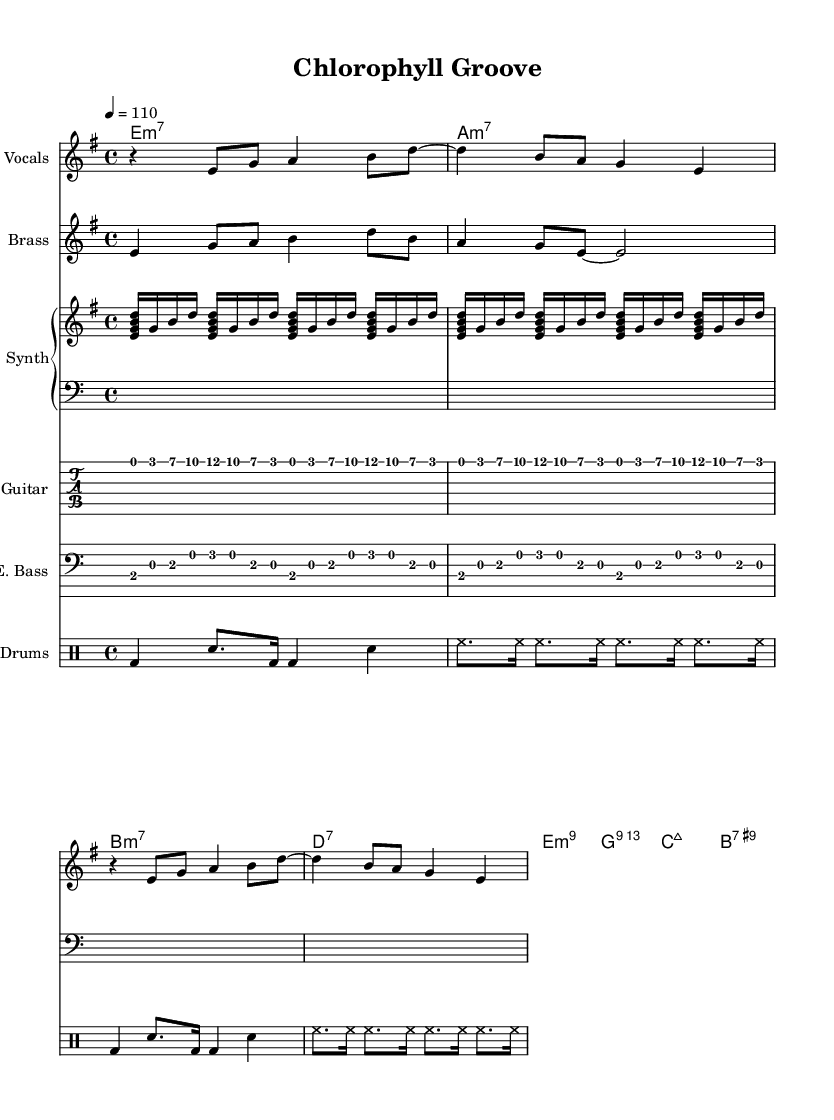What is the key signature of this music? The key signature is E minor, which has one sharp (F#) and follows the standard notation in the beginning of the staff.
Answer: E minor What is the time signature of this music? The time signature is found at the beginning of the sheet music; it shows 4 over 4, indicating four beats per measure, which is common in funk music.
Answer: 4/4 What is the tempo marking for this piece? The tempo marking, typically found above the staff, indicates "4 = 110", meaning one quarter note is equal to 110 beats per minute.
Answer: 110 Which instruments are featured in the score? The score clearly lists several instruments: Vocals, Brass, Synth, Electric Guitar, Electric Bass, and Drums, which are all specified in their respective staves.
Answer: Vocals, Brass, Synth, Electric Guitar, Electric Bass, Drums What chord is played first in the progression? The first chord in the chord names section is E minor 7, indicated at the beginning of the chord progression, which sets the tonal foundation for the piece.
Answer: E minor 7 How many times is the main electric guitar riff repeated? By looking at the electric guitar part, it is noted that the riff is explicitly noted to repeat twice in the score, as indicated by the repeat markings.
Answer: 2 What rhythmic division is used in the drum patterns? The drum section indicates a mix of quarter, eighth, and sixteenth notes, showcasing the syncopated groove typical of funk music, particularly in the alternating patterns shown.
Answer: Mix of quarter, eighth, and sixteenth notes 